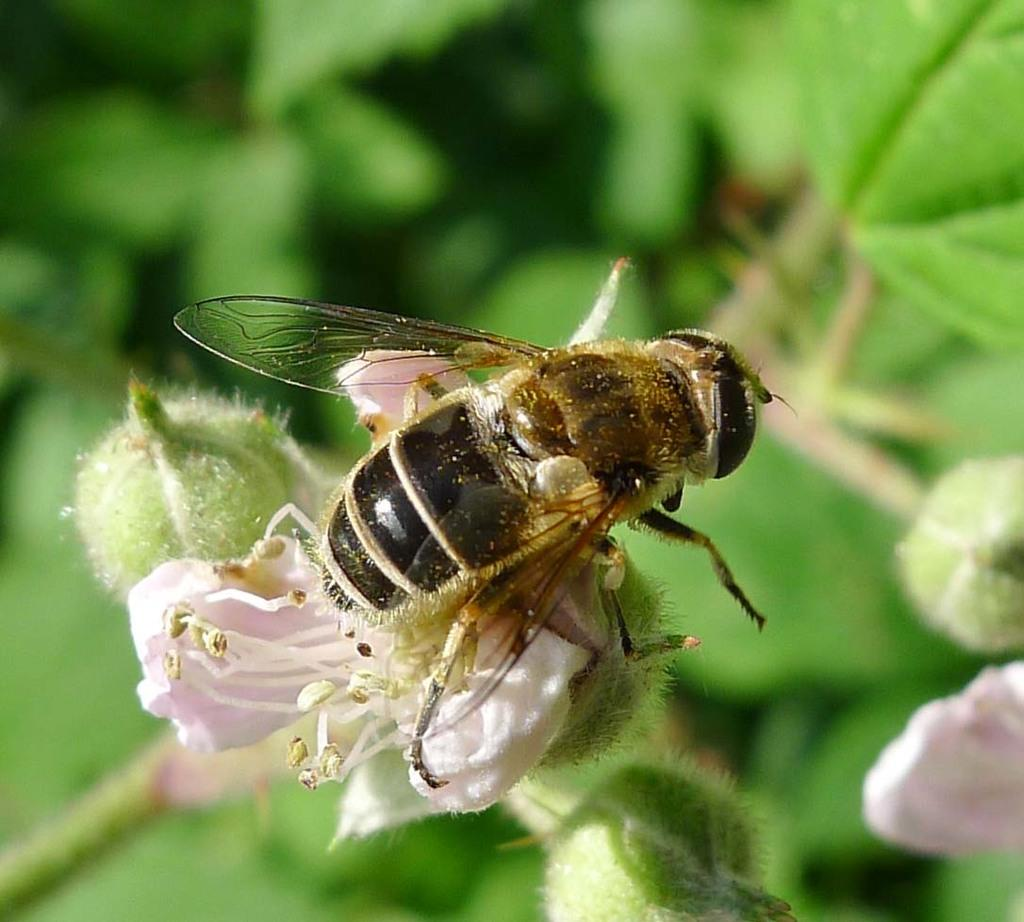What is the main subject of the image? The main subject of the image is a bee. Where is the bee located in the image? The bee is sitting on a flower. What can be seen in the background of the image? There are green leaves and small buds of the flower in the background of the image. What type of bubble can be seen in the image? There is no bubble present in the image. How many screws can be seen holding the flower together in the image? There are no screws visible in the image, as flowers are not held together by screws. 